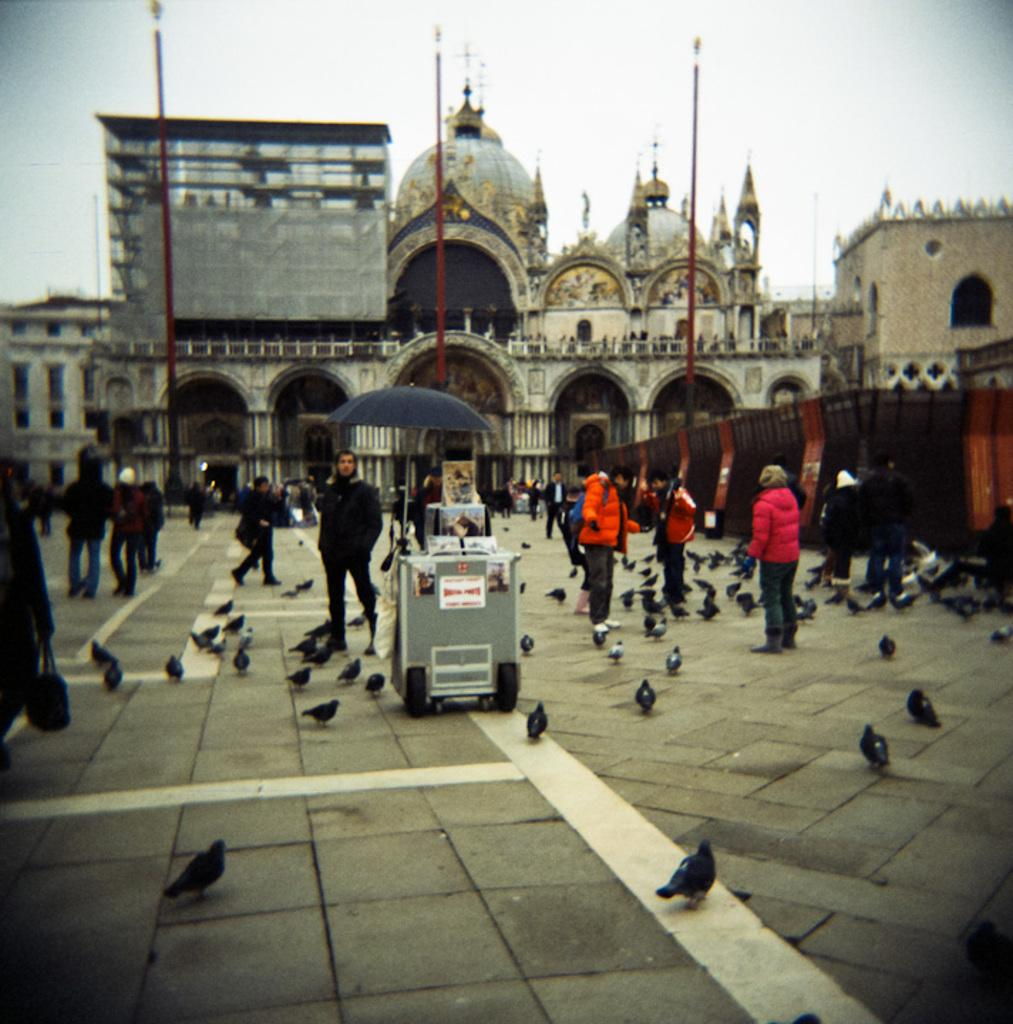What type of animals can be seen in the image? Birds can be seen in the image. Are there any human figures present in the image? Yes, there are people in the image. What can be seen in the background of the image? There is a building in the background of the image. What type of stone is being used to capture the birds in the image? There is no stone present in the image, and the birds are not being captured. 